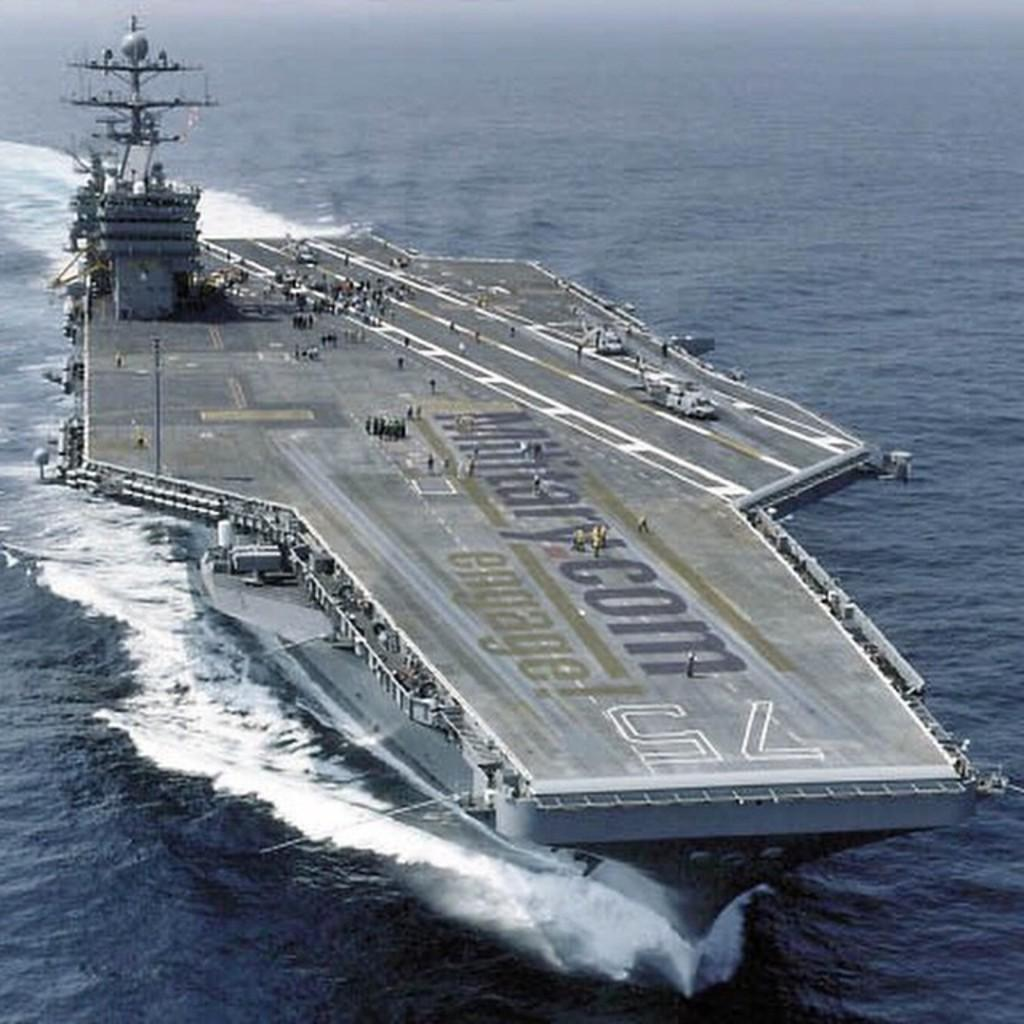What is the main subject of the picture? The main subject of the picture is a war ship. Are there any people on the war ship? Yes, people are visible on the war ship. What type of vehicle is present on the war ship? There is an aircraft on the war ship. What else can be seen on the war ship besides people and the aircraft? There are other objects on the war ship. What is the setting of the picture? The picture features a water body in the background. What type of plants can be seen growing on the war ship in the image? There are no plants visible on the war ship in the image. How does the war ship aid in the digestion of food for the people on board? The war ship is not involved in the digestion of food for the people on board; it is a military vessel designed for defense and transportation purposes. 